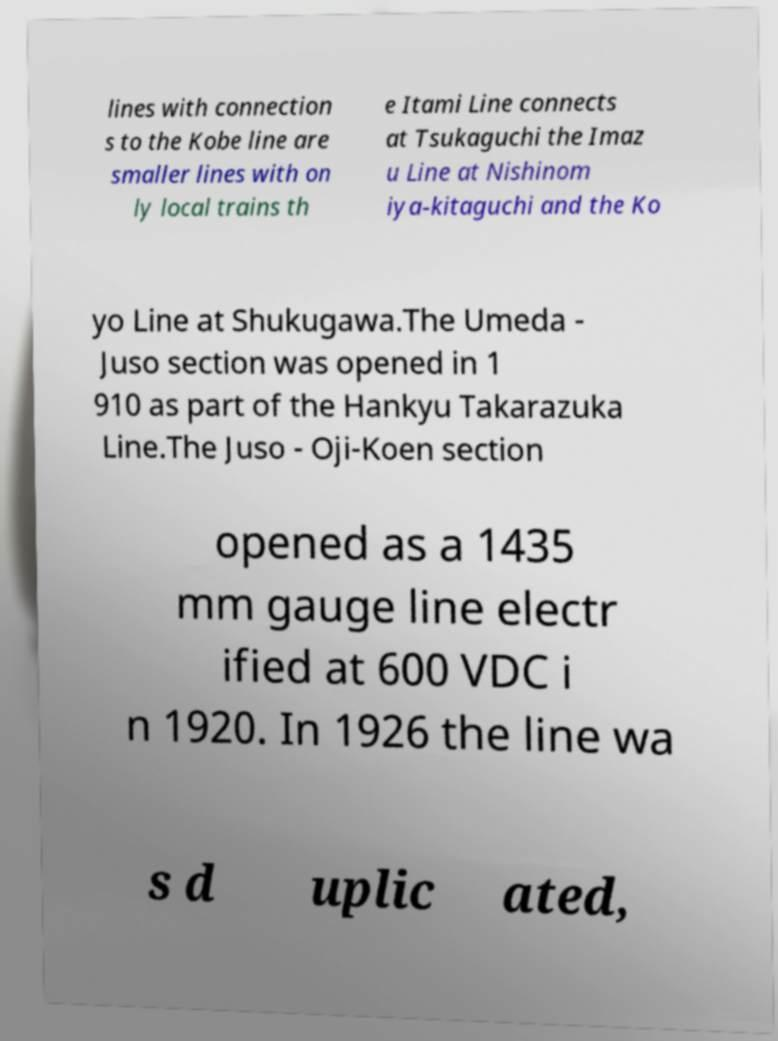Can you accurately transcribe the text from the provided image for me? lines with connection s to the Kobe line are smaller lines with on ly local trains th e Itami Line connects at Tsukaguchi the Imaz u Line at Nishinom iya-kitaguchi and the Ko yo Line at Shukugawa.The Umeda - Juso section was opened in 1 910 as part of the Hankyu Takarazuka Line.The Juso - Oji-Koen section opened as a 1435 mm gauge line electr ified at 600 VDC i n 1920. In 1926 the line wa s d uplic ated, 